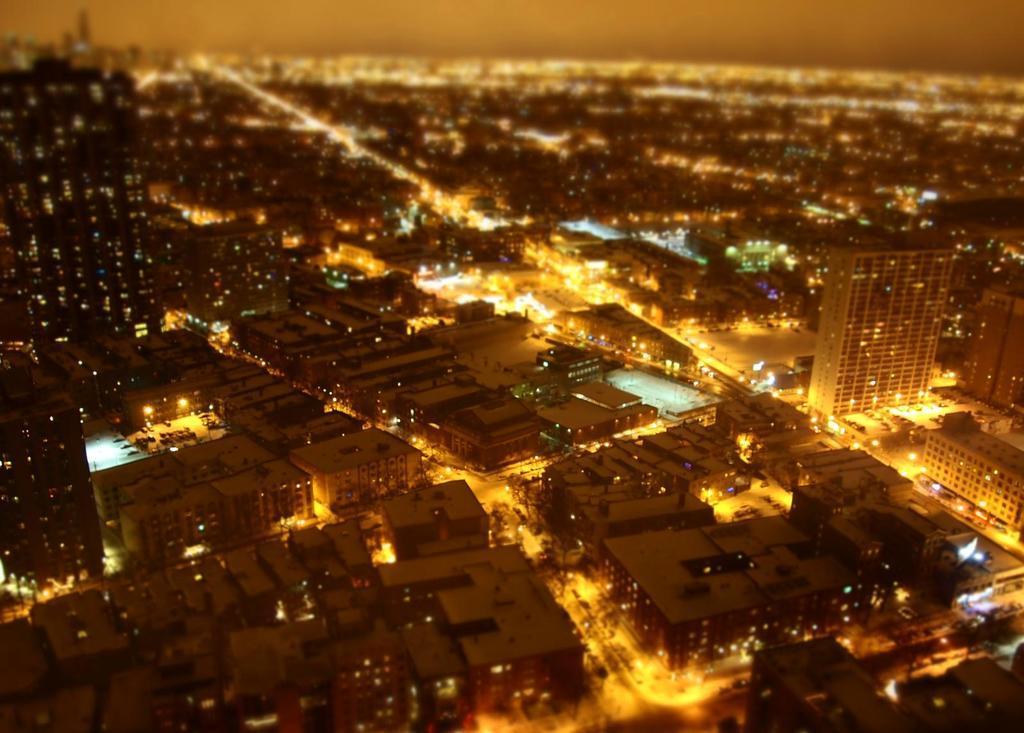Please provide a concise description of this image. This image is an aerial view of buildings, roads and vehicles. We can see lights. 